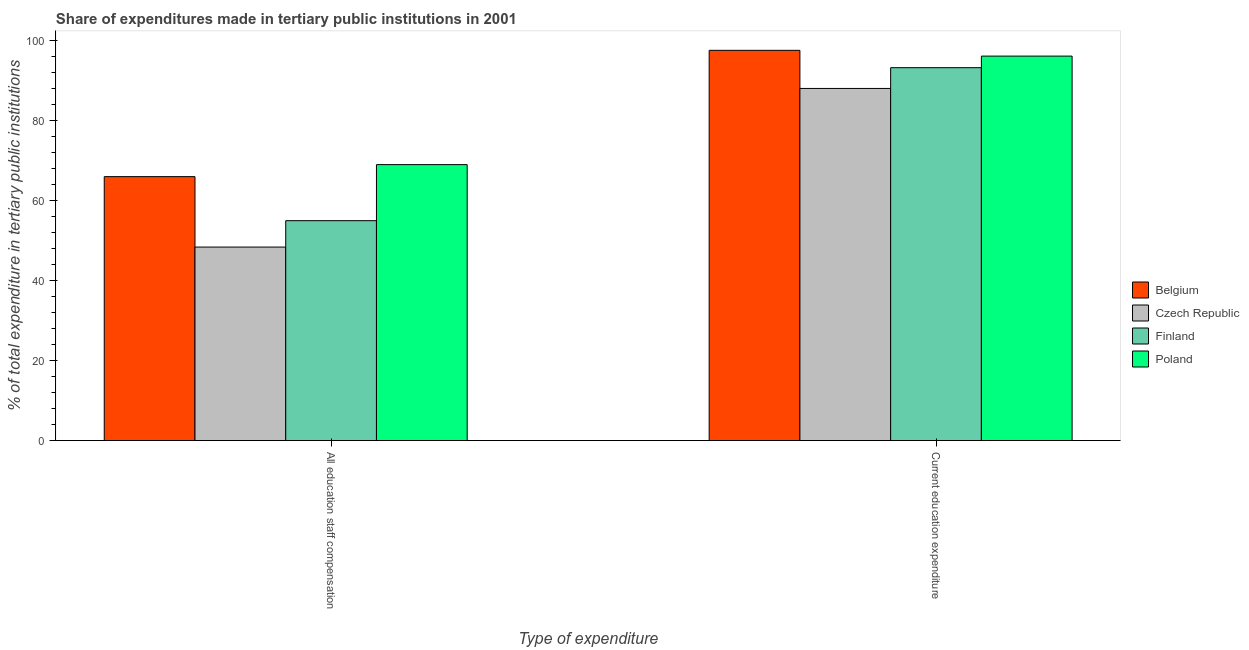How many different coloured bars are there?
Keep it short and to the point. 4. How many groups of bars are there?
Provide a short and direct response. 2. Are the number of bars on each tick of the X-axis equal?
Keep it short and to the point. Yes. What is the label of the 1st group of bars from the left?
Your answer should be compact. All education staff compensation. What is the expenditure in staff compensation in Finland?
Give a very brief answer. 55. Across all countries, what is the maximum expenditure in staff compensation?
Offer a very short reply. 69.02. Across all countries, what is the minimum expenditure in education?
Make the answer very short. 88.07. In which country was the expenditure in staff compensation maximum?
Keep it short and to the point. Poland. In which country was the expenditure in education minimum?
Your response must be concise. Czech Republic. What is the total expenditure in staff compensation in the graph?
Offer a terse response. 238.44. What is the difference between the expenditure in staff compensation in Poland and that in Finland?
Your answer should be very brief. 14.02. What is the difference between the expenditure in staff compensation in Poland and the expenditure in education in Czech Republic?
Make the answer very short. -19.05. What is the average expenditure in education per country?
Provide a short and direct response. 93.78. What is the difference between the expenditure in education and expenditure in staff compensation in Poland?
Offer a terse response. 27.14. In how many countries, is the expenditure in education greater than 72 %?
Make the answer very short. 4. What is the ratio of the expenditure in staff compensation in Czech Republic to that in Finland?
Give a very brief answer. 0.88. Is the expenditure in staff compensation in Czech Republic less than that in Finland?
Keep it short and to the point. Yes. In how many countries, is the expenditure in staff compensation greater than the average expenditure in staff compensation taken over all countries?
Ensure brevity in your answer.  2. What does the 2nd bar from the left in All education staff compensation represents?
Give a very brief answer. Czech Republic. What does the 1st bar from the right in Current education expenditure represents?
Keep it short and to the point. Poland. How many bars are there?
Make the answer very short. 8. How many countries are there in the graph?
Provide a short and direct response. 4. What is the difference between two consecutive major ticks on the Y-axis?
Provide a succinct answer. 20. Are the values on the major ticks of Y-axis written in scientific E-notation?
Offer a terse response. No. Does the graph contain any zero values?
Your answer should be compact. No. How many legend labels are there?
Your response must be concise. 4. How are the legend labels stacked?
Keep it short and to the point. Vertical. What is the title of the graph?
Provide a succinct answer. Share of expenditures made in tertiary public institutions in 2001. What is the label or title of the X-axis?
Provide a short and direct response. Type of expenditure. What is the label or title of the Y-axis?
Make the answer very short. % of total expenditure in tertiary public institutions. What is the % of total expenditure in tertiary public institutions of Belgium in All education staff compensation?
Keep it short and to the point. 66.02. What is the % of total expenditure in tertiary public institutions of Czech Republic in All education staff compensation?
Provide a short and direct response. 48.4. What is the % of total expenditure in tertiary public institutions of Finland in All education staff compensation?
Provide a short and direct response. 55. What is the % of total expenditure in tertiary public institutions of Poland in All education staff compensation?
Make the answer very short. 69.02. What is the % of total expenditure in tertiary public institutions of Belgium in Current education expenditure?
Your answer should be very brief. 97.61. What is the % of total expenditure in tertiary public institutions of Czech Republic in Current education expenditure?
Keep it short and to the point. 88.07. What is the % of total expenditure in tertiary public institutions of Finland in Current education expenditure?
Give a very brief answer. 93.27. What is the % of total expenditure in tertiary public institutions in Poland in Current education expenditure?
Your response must be concise. 96.16. Across all Type of expenditure, what is the maximum % of total expenditure in tertiary public institutions in Belgium?
Your response must be concise. 97.61. Across all Type of expenditure, what is the maximum % of total expenditure in tertiary public institutions in Czech Republic?
Provide a succinct answer. 88.07. Across all Type of expenditure, what is the maximum % of total expenditure in tertiary public institutions in Finland?
Offer a terse response. 93.27. Across all Type of expenditure, what is the maximum % of total expenditure in tertiary public institutions in Poland?
Your answer should be very brief. 96.16. Across all Type of expenditure, what is the minimum % of total expenditure in tertiary public institutions of Belgium?
Your answer should be very brief. 66.02. Across all Type of expenditure, what is the minimum % of total expenditure in tertiary public institutions of Czech Republic?
Offer a very short reply. 48.4. Across all Type of expenditure, what is the minimum % of total expenditure in tertiary public institutions of Finland?
Offer a terse response. 55. Across all Type of expenditure, what is the minimum % of total expenditure in tertiary public institutions of Poland?
Keep it short and to the point. 69.02. What is the total % of total expenditure in tertiary public institutions in Belgium in the graph?
Offer a very short reply. 163.62. What is the total % of total expenditure in tertiary public institutions of Czech Republic in the graph?
Keep it short and to the point. 136.47. What is the total % of total expenditure in tertiary public institutions of Finland in the graph?
Offer a very short reply. 148.27. What is the total % of total expenditure in tertiary public institutions of Poland in the graph?
Your answer should be compact. 165.19. What is the difference between the % of total expenditure in tertiary public institutions of Belgium in All education staff compensation and that in Current education expenditure?
Your response must be concise. -31.59. What is the difference between the % of total expenditure in tertiary public institutions in Czech Republic in All education staff compensation and that in Current education expenditure?
Give a very brief answer. -39.67. What is the difference between the % of total expenditure in tertiary public institutions in Finland in All education staff compensation and that in Current education expenditure?
Provide a short and direct response. -38.27. What is the difference between the % of total expenditure in tertiary public institutions in Poland in All education staff compensation and that in Current education expenditure?
Ensure brevity in your answer.  -27.14. What is the difference between the % of total expenditure in tertiary public institutions in Belgium in All education staff compensation and the % of total expenditure in tertiary public institutions in Czech Republic in Current education expenditure?
Provide a succinct answer. -22.06. What is the difference between the % of total expenditure in tertiary public institutions in Belgium in All education staff compensation and the % of total expenditure in tertiary public institutions in Finland in Current education expenditure?
Ensure brevity in your answer.  -27.25. What is the difference between the % of total expenditure in tertiary public institutions of Belgium in All education staff compensation and the % of total expenditure in tertiary public institutions of Poland in Current education expenditure?
Ensure brevity in your answer.  -30.15. What is the difference between the % of total expenditure in tertiary public institutions of Czech Republic in All education staff compensation and the % of total expenditure in tertiary public institutions of Finland in Current education expenditure?
Provide a short and direct response. -44.87. What is the difference between the % of total expenditure in tertiary public institutions in Czech Republic in All education staff compensation and the % of total expenditure in tertiary public institutions in Poland in Current education expenditure?
Your answer should be very brief. -47.76. What is the difference between the % of total expenditure in tertiary public institutions of Finland in All education staff compensation and the % of total expenditure in tertiary public institutions of Poland in Current education expenditure?
Give a very brief answer. -41.16. What is the average % of total expenditure in tertiary public institutions of Belgium per Type of expenditure?
Keep it short and to the point. 81.81. What is the average % of total expenditure in tertiary public institutions in Czech Republic per Type of expenditure?
Your answer should be compact. 68.24. What is the average % of total expenditure in tertiary public institutions in Finland per Type of expenditure?
Your answer should be compact. 74.13. What is the average % of total expenditure in tertiary public institutions in Poland per Type of expenditure?
Your response must be concise. 82.59. What is the difference between the % of total expenditure in tertiary public institutions of Belgium and % of total expenditure in tertiary public institutions of Czech Republic in All education staff compensation?
Your answer should be compact. 17.62. What is the difference between the % of total expenditure in tertiary public institutions in Belgium and % of total expenditure in tertiary public institutions in Finland in All education staff compensation?
Your answer should be compact. 11.02. What is the difference between the % of total expenditure in tertiary public institutions of Belgium and % of total expenditure in tertiary public institutions of Poland in All education staff compensation?
Your answer should be very brief. -3.01. What is the difference between the % of total expenditure in tertiary public institutions in Czech Republic and % of total expenditure in tertiary public institutions in Finland in All education staff compensation?
Your response must be concise. -6.6. What is the difference between the % of total expenditure in tertiary public institutions in Czech Republic and % of total expenditure in tertiary public institutions in Poland in All education staff compensation?
Your answer should be compact. -20.62. What is the difference between the % of total expenditure in tertiary public institutions in Finland and % of total expenditure in tertiary public institutions in Poland in All education staff compensation?
Ensure brevity in your answer.  -14.02. What is the difference between the % of total expenditure in tertiary public institutions of Belgium and % of total expenditure in tertiary public institutions of Czech Republic in Current education expenditure?
Make the answer very short. 9.53. What is the difference between the % of total expenditure in tertiary public institutions in Belgium and % of total expenditure in tertiary public institutions in Finland in Current education expenditure?
Your response must be concise. 4.34. What is the difference between the % of total expenditure in tertiary public institutions in Belgium and % of total expenditure in tertiary public institutions in Poland in Current education expenditure?
Offer a very short reply. 1.44. What is the difference between the % of total expenditure in tertiary public institutions in Czech Republic and % of total expenditure in tertiary public institutions in Finland in Current education expenditure?
Provide a short and direct response. -5.2. What is the difference between the % of total expenditure in tertiary public institutions of Czech Republic and % of total expenditure in tertiary public institutions of Poland in Current education expenditure?
Your answer should be compact. -8.09. What is the difference between the % of total expenditure in tertiary public institutions of Finland and % of total expenditure in tertiary public institutions of Poland in Current education expenditure?
Make the answer very short. -2.9. What is the ratio of the % of total expenditure in tertiary public institutions in Belgium in All education staff compensation to that in Current education expenditure?
Your answer should be compact. 0.68. What is the ratio of the % of total expenditure in tertiary public institutions of Czech Republic in All education staff compensation to that in Current education expenditure?
Keep it short and to the point. 0.55. What is the ratio of the % of total expenditure in tertiary public institutions in Finland in All education staff compensation to that in Current education expenditure?
Offer a very short reply. 0.59. What is the ratio of the % of total expenditure in tertiary public institutions of Poland in All education staff compensation to that in Current education expenditure?
Ensure brevity in your answer.  0.72. What is the difference between the highest and the second highest % of total expenditure in tertiary public institutions of Belgium?
Offer a very short reply. 31.59. What is the difference between the highest and the second highest % of total expenditure in tertiary public institutions of Czech Republic?
Your answer should be compact. 39.67. What is the difference between the highest and the second highest % of total expenditure in tertiary public institutions in Finland?
Offer a terse response. 38.27. What is the difference between the highest and the second highest % of total expenditure in tertiary public institutions in Poland?
Ensure brevity in your answer.  27.14. What is the difference between the highest and the lowest % of total expenditure in tertiary public institutions of Belgium?
Your answer should be compact. 31.59. What is the difference between the highest and the lowest % of total expenditure in tertiary public institutions in Czech Republic?
Your answer should be very brief. 39.67. What is the difference between the highest and the lowest % of total expenditure in tertiary public institutions in Finland?
Give a very brief answer. 38.27. What is the difference between the highest and the lowest % of total expenditure in tertiary public institutions of Poland?
Your answer should be very brief. 27.14. 